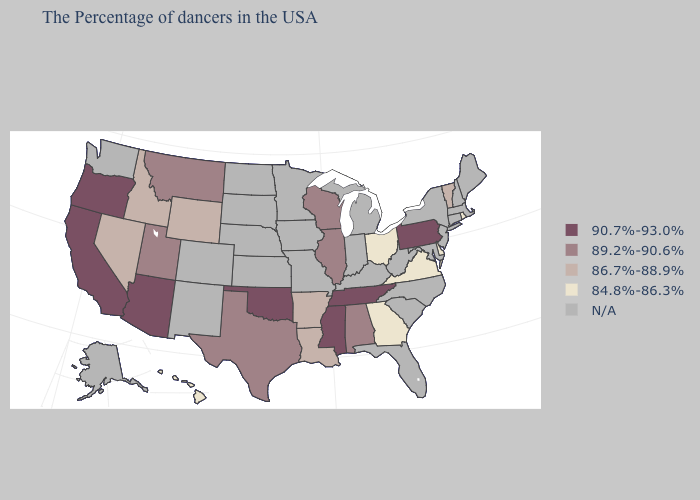What is the value of Pennsylvania?
Quick response, please. 90.7%-93.0%. Which states hav the highest value in the MidWest?
Short answer required. Wisconsin, Illinois. What is the highest value in the West ?
Short answer required. 90.7%-93.0%. Among the states that border Connecticut , which have the lowest value?
Concise answer only. Rhode Island. Name the states that have a value in the range 90.7%-93.0%?
Give a very brief answer. Pennsylvania, Tennessee, Mississippi, Oklahoma, Arizona, California, Oregon. What is the value of Wyoming?
Answer briefly. 86.7%-88.9%. Name the states that have a value in the range 90.7%-93.0%?
Short answer required. Pennsylvania, Tennessee, Mississippi, Oklahoma, Arizona, California, Oregon. What is the value of Minnesota?
Keep it brief. N/A. What is the value of California?
Write a very short answer. 90.7%-93.0%. Which states have the lowest value in the West?
Keep it brief. Hawaii. Which states have the highest value in the USA?
Answer briefly. Pennsylvania, Tennessee, Mississippi, Oklahoma, Arizona, California, Oregon. 